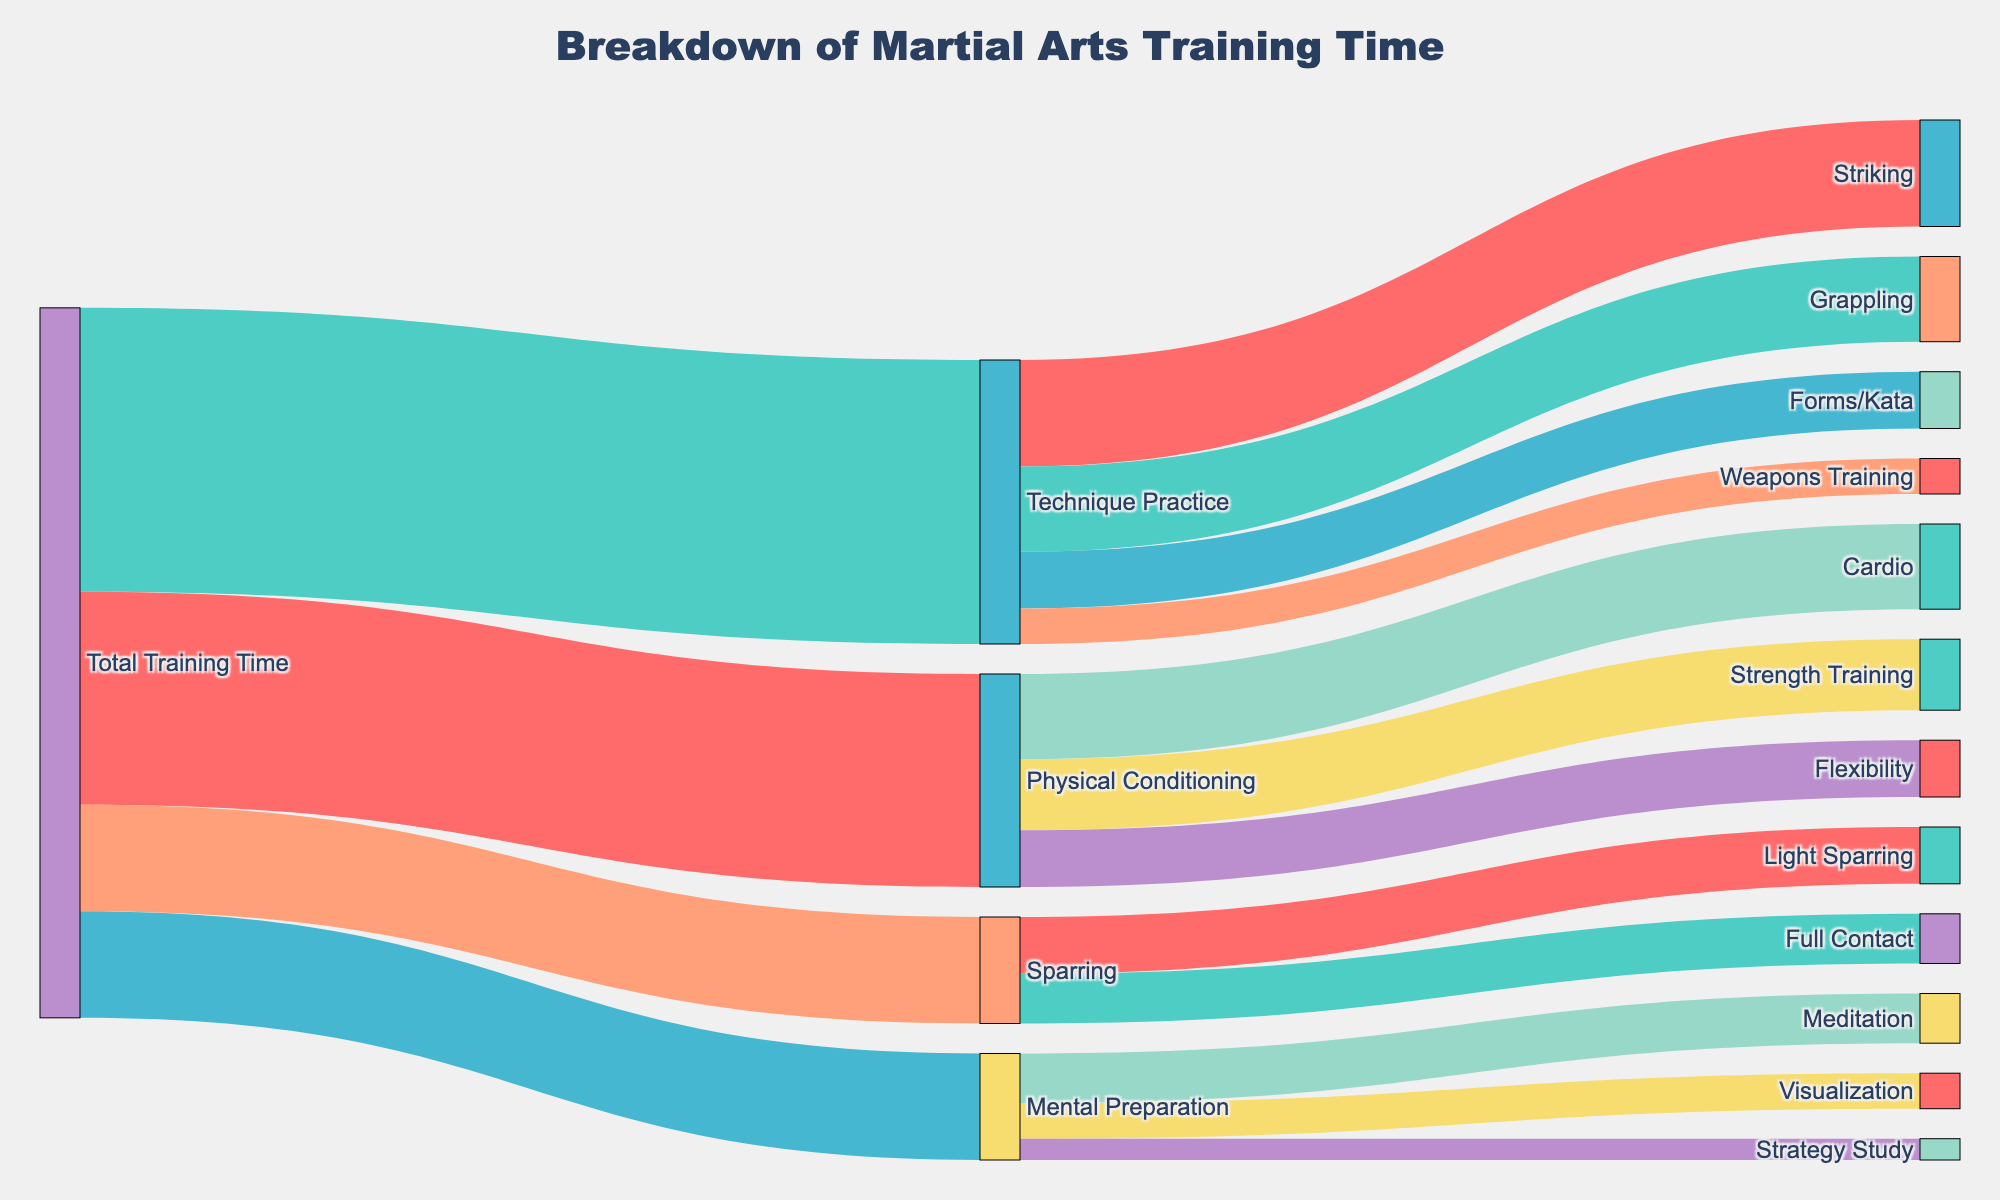What's the title of the figure? The title is usually located at the top of the figure. By reading it directly, we can understand the main topic of the diagram.
Answer: Breakdown of Martial Arts Training Time What are the main categories of training time breakdown? We identify the main categories by looking at the large branches connecting directly to "Total Training Time." These branches represent major categories such as Physical Conditioning, Technique Practice, Mental Preparation, and Sparring.
Answer: Physical Conditioning, Technique Practice, Mental Preparation, Sparring How much time is spent on Technique Practice? The value of the link between "Total Training Time" and "Technique Practice" indicates the time spent. It's specifically labeled on the diagram.
Answer: 40 What is the sum of time spent on Cardio and Strength Training? To find the total, add the values of the smaller branches corresponding to Cardio and Strength Training under Physical Conditioning (12 + 10).
Answer: 22 Which subcategory under Technique Practice receives the least amount of time? By comparing the values of the branches under Technique Practice (Striking, Grappling, Forms/Kata, Weapons Training), the subcategory with the smallest number is identified.
Answer: Weapons Training Is more time spent on Mental Preparation or Sparring? Compare the values of the links connecting "Total Training Time" to "Mental Preparation" and "Sparring." The larger value indicates more time spent.
Answer: Same amount (15 each) How much more time is spent on Flexibility compared to Visualization in training? Subtract the value of time spent on Visualization from the time spent on Flexibility under their respective categories (8 - 5).
Answer: 3 Which activity in Physical Conditioning takes up the most time? By looking at the values of the subcategories under Physical Conditioning (Cardio, Strength Training, Flexibility), the one with the highest number is the answer.
Answer: Cardio What is the total time allocated to Mental Preparation activities? Sum the values of all branches under Mental Preparation (7 for Meditation, 5 for Visualization, 3 for Strategy Study).
Answer: 15 How does the time spent on Striking compare with the time spent on Cardio and Meditation combined? First, sum the values for Cardio and Meditation (12 + 7 = 19). Then, compare this sum with Striking's value (15).
Answer: Less 